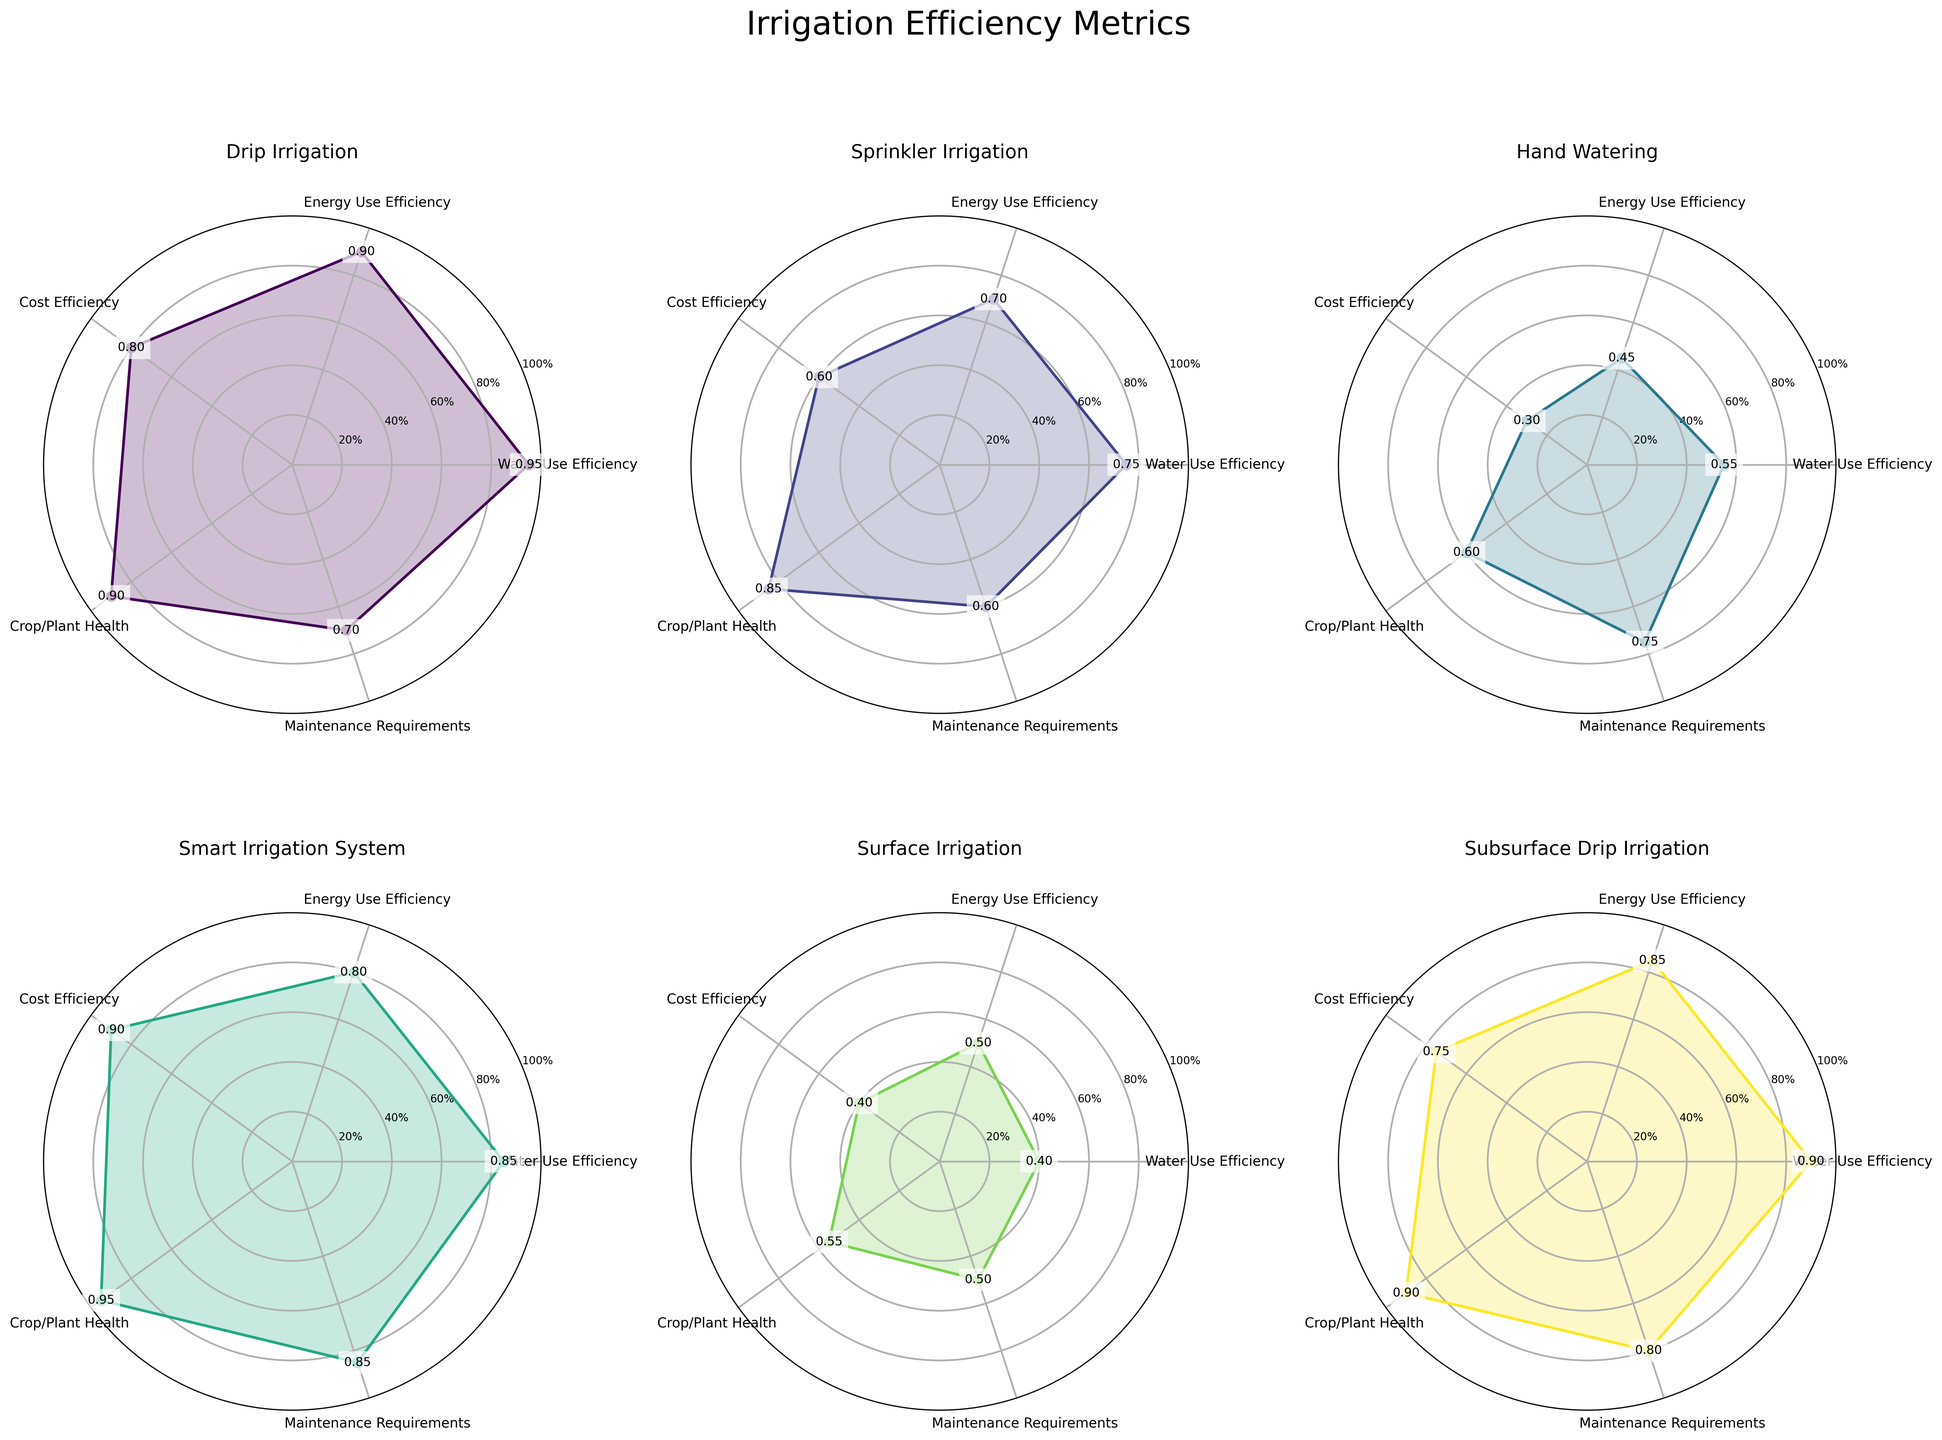What is the title of the figure? The title of the figure is displayed prominently at the top. It reads "Irrigation Efficiency Metrics".
Answer: Irrigation Efficiency Metrics Which irrigation method has the highest value for Water Use Efficiency? By examining each subplot and finding the Water Use Efficiency column, which is the first metric, we can see that Drip Irrigation has the highest value, which is 0.95.
Answer: Drip Irrigation What's the average Maintenance Requirements score across all irrigation methods? Maintenance Requirements scores for each method: Drip (0.70), Sprinkler (0.60), Hand Watering (0.75), Smart (0.85), Surface (0.50), Subsurface Drip (0.80). Calculate the average: (0.70 + 0.60 + 0.75 + 0.85 + 0.50 + 0.80) / 6 = 0.70.
Answer: 0.70 Which metric shows the most significant improvement in Smart Irrigation Systems compared to Hand Watering? Compare each metric of Smart Irrigation Systems and Hand Watering: Water Use Efficiency (0.85 - 0.55 = 0.30), Energy Use Efficiency (0.80 - 0.45 = 0.35), Cost Efficiency (0.90 - 0.30= 0.60), Crop/Plant Health (0.95 - 0.60 = 0.35), Maintenance Requirements (0.85 - 0.75 = 0.10). The largest difference is in Cost Efficiency.
Answer: Cost Efficiency Which irrigation methods have a Crop/Plant Health score of 0.90 or above? Check the Crop/Plant Health values for each method: Drip (0.90), Smart (0.95), and Subsurface Drip (0.90).
Answer: Drip Irrigation, Smart Irrigation System, Subsurface Drip Irrigation How does Sprinkler Irrigation compare to Surface Irrigation in terms of Cost Efficiency? Compare the Cost Efficiency values of Sprinkler and Surface: Sprinkler (0.60), Surface (0.40). Sprinkler has a higher Cost Efficiency.
Answer: Sprinkler Irrigation is higher What is the range of Energy Use Efficiency scores across all irrigation methods? Find the highest and lowest Energy Use Efficiency scores: highest (Drip and Subsurface Drip at 0.90), lowest (Hand Watering at 0.45). Calculate the range: 0.90 - 0.45 = 0.45.
Answer: 0.45 What is the median value of Cost Efficiency for all irrigation methods? List the Cost Efficiency values: Drip (0.80), Sprinkler (0.60), Hand Watering (0.30), Smart (0.90), Surface (0.40), Subsurface Drip (0.75). Arrange them: 0.30, 0.40, 0.60, 0.75, 0.80, 0.90. Median is the middle value of the sorted list (average of 0.60 and 0.75): (0.60 + 0.75) / 2 = 0.675.
Answer: 0.675 